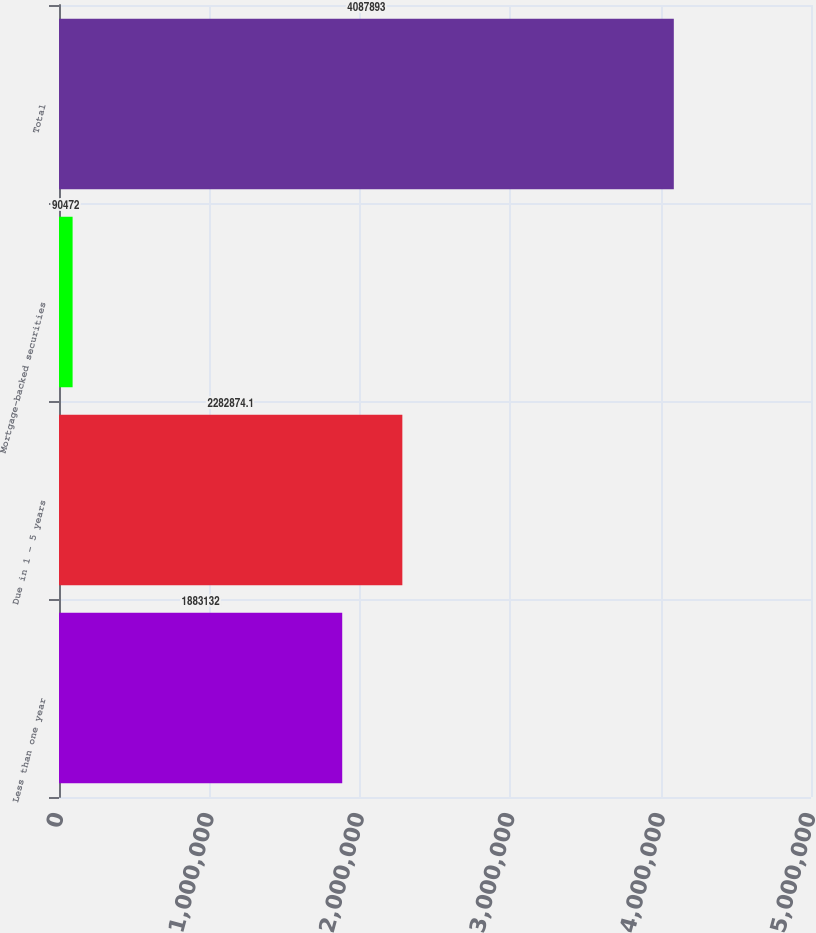Convert chart to OTSL. <chart><loc_0><loc_0><loc_500><loc_500><bar_chart><fcel>Less than one year<fcel>Due in 1 - 5 years<fcel>Mortgage-backed securities<fcel>Total<nl><fcel>1.88313e+06<fcel>2.28287e+06<fcel>90472<fcel>4.08789e+06<nl></chart> 